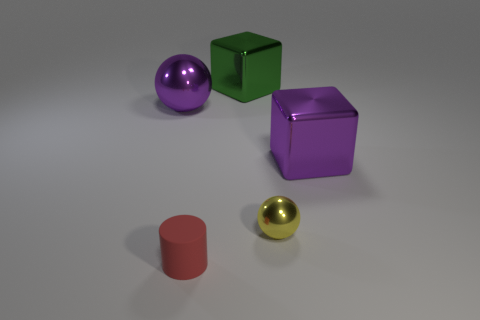Add 2 small balls. How many objects exist? 7 Subtract 1 cylinders. How many cylinders are left? 0 Add 2 green things. How many green things are left? 3 Add 2 small balls. How many small balls exist? 3 Subtract 0 green cylinders. How many objects are left? 5 Subtract all blocks. How many objects are left? 3 Subtract all green balls. Subtract all blue cubes. How many balls are left? 2 Subtract all tiny red matte cylinders. Subtract all green shiny objects. How many objects are left? 3 